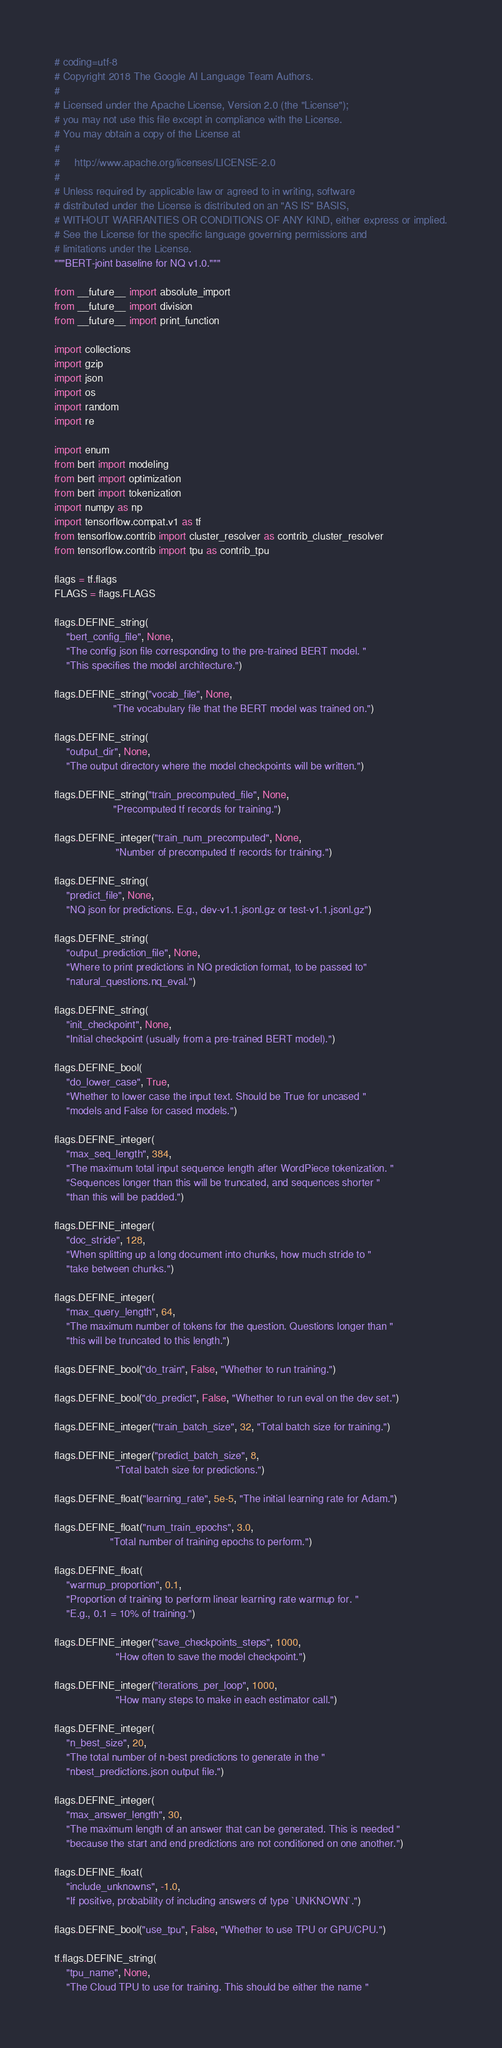Convert code to text. <code><loc_0><loc_0><loc_500><loc_500><_Python_># coding=utf-8
# Copyright 2018 The Google AI Language Team Authors.
#
# Licensed under the Apache License, Version 2.0 (the "License");
# you may not use this file except in compliance with the License.
# You may obtain a copy of the License at
#
#     http://www.apache.org/licenses/LICENSE-2.0
#
# Unless required by applicable law or agreed to in writing, software
# distributed under the License is distributed on an "AS IS" BASIS,
# WITHOUT WARRANTIES OR CONDITIONS OF ANY KIND, either express or implied.
# See the License for the specific language governing permissions and
# limitations under the License.
"""BERT-joint baseline for NQ v1.0."""

from __future__ import absolute_import
from __future__ import division
from __future__ import print_function

import collections
import gzip
import json
import os
import random
import re

import enum
from bert import modeling
from bert import optimization
from bert import tokenization
import numpy as np
import tensorflow.compat.v1 as tf
from tensorflow.contrib import cluster_resolver as contrib_cluster_resolver
from tensorflow.contrib import tpu as contrib_tpu

flags = tf.flags
FLAGS = flags.FLAGS

flags.DEFINE_string(
    "bert_config_file", None,
    "The config json file corresponding to the pre-trained BERT model. "
    "This specifies the model architecture.")

flags.DEFINE_string("vocab_file", None,
                    "The vocabulary file that the BERT model was trained on.")

flags.DEFINE_string(
    "output_dir", None,
    "The output directory where the model checkpoints will be written.")

flags.DEFINE_string("train_precomputed_file", None,
                    "Precomputed tf records for training.")

flags.DEFINE_integer("train_num_precomputed", None,
                     "Number of precomputed tf records for training.")

flags.DEFINE_string(
    "predict_file", None,
    "NQ json for predictions. E.g., dev-v1.1.jsonl.gz or test-v1.1.jsonl.gz")

flags.DEFINE_string(
    "output_prediction_file", None,
    "Where to print predictions in NQ prediction format, to be passed to"
    "natural_questions.nq_eval.")

flags.DEFINE_string(
    "init_checkpoint", None,
    "Initial checkpoint (usually from a pre-trained BERT model).")

flags.DEFINE_bool(
    "do_lower_case", True,
    "Whether to lower case the input text. Should be True for uncased "
    "models and False for cased models.")

flags.DEFINE_integer(
    "max_seq_length", 384,
    "The maximum total input sequence length after WordPiece tokenization. "
    "Sequences longer than this will be truncated, and sequences shorter "
    "than this will be padded.")

flags.DEFINE_integer(
    "doc_stride", 128,
    "When splitting up a long document into chunks, how much stride to "
    "take between chunks.")

flags.DEFINE_integer(
    "max_query_length", 64,
    "The maximum number of tokens for the question. Questions longer than "
    "this will be truncated to this length.")

flags.DEFINE_bool("do_train", False, "Whether to run training.")

flags.DEFINE_bool("do_predict", False, "Whether to run eval on the dev set.")

flags.DEFINE_integer("train_batch_size", 32, "Total batch size for training.")

flags.DEFINE_integer("predict_batch_size", 8,
                     "Total batch size for predictions.")

flags.DEFINE_float("learning_rate", 5e-5, "The initial learning rate for Adam.")

flags.DEFINE_float("num_train_epochs", 3.0,
                   "Total number of training epochs to perform.")

flags.DEFINE_float(
    "warmup_proportion", 0.1,
    "Proportion of training to perform linear learning rate warmup for. "
    "E.g., 0.1 = 10% of training.")

flags.DEFINE_integer("save_checkpoints_steps", 1000,
                     "How often to save the model checkpoint.")

flags.DEFINE_integer("iterations_per_loop", 1000,
                     "How many steps to make in each estimator call.")

flags.DEFINE_integer(
    "n_best_size", 20,
    "The total number of n-best predictions to generate in the "
    "nbest_predictions.json output file.")

flags.DEFINE_integer(
    "max_answer_length", 30,
    "The maximum length of an answer that can be generated. This is needed "
    "because the start and end predictions are not conditioned on one another.")

flags.DEFINE_float(
    "include_unknowns", -1.0,
    "If positive, probability of including answers of type `UNKNOWN`.")

flags.DEFINE_bool("use_tpu", False, "Whether to use TPU or GPU/CPU.")

tf.flags.DEFINE_string(
    "tpu_name", None,
    "The Cloud TPU to use for training. This should be either the name "</code> 